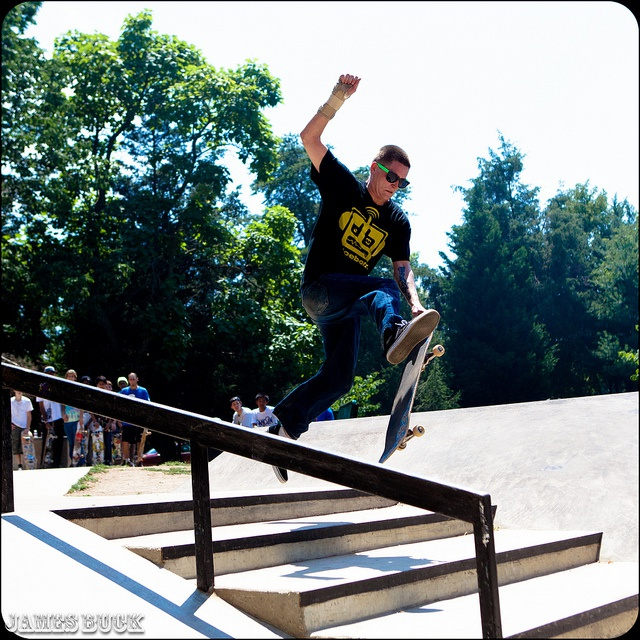Describe the objects in this image and their specific colors. I can see people in black, brown, white, and maroon tones, skateboard in black, darkgray, gray, and lightgray tones, people in black, darkgray, gray, and maroon tones, people in black, maroon, gray, and brown tones, and people in black, darkgray, and gray tones in this image. 